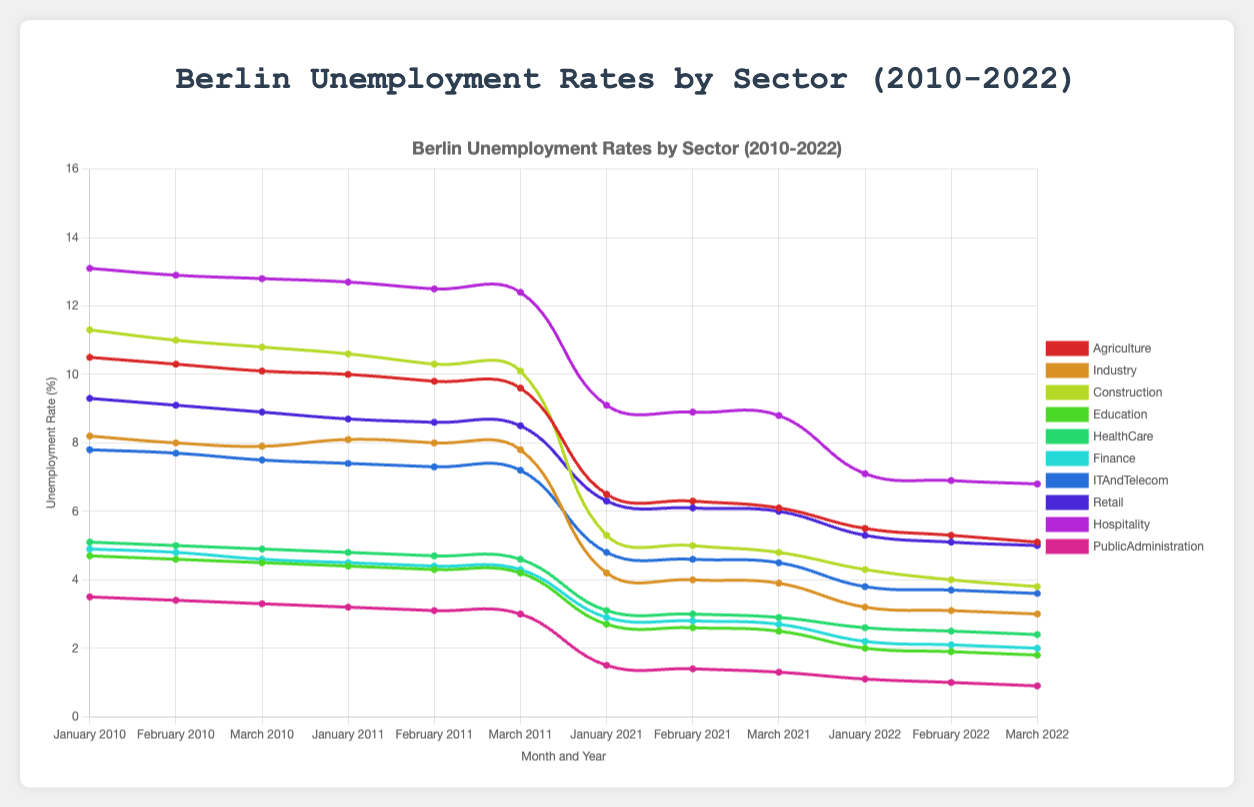What sector experienced the highest unemployment rate in January 2010? To identify the sector with the highest unemployment rate, look at the January 2010 data and compare all the sectors' unemployment rates. The highest value is 13.1 for the Hospitality sector.
Answer: Hospitality Which sector had the largest decrease in the unemployment rate from January 2011 to January 2022? To find the sector with the largest decrease, subtract the January 2022 unemployment rates from the January 2011 rates for each sector and identify the maximum difference. The most significant decrease is in the Hospitality sector, from 12.7 to 7.1, which is a drop of 5.6 percentage points.
Answer: Hospitality What is the average unemployment rate in the Finance sector across the years 2010 to 2022 for the month of January? To find the average, sum the unemployment rates for January from 2010 (4.9), 2011 (4.5), 2021 (2.9), and 2022 (2.2), then divide by the number of years. (4.9 + 4.5 + 2.9 + 2.2) / 4 = 3.625.
Answer: 3.625 Compare the unemployment rate in the Industry sector in March 2010 and March 2022. Which month had a lower rate? Compare the March 2010 and March 2022 rates for the Industry sector. March 2010 had a rate of 7.9% and March 2022 had 3.0%. Thus, March 2022 had a lower rate.
Answer: March 2022 Between January and March 2021, did the Retail sector experience an increase or decrease in the unemployment rate? By how much? Find the unemployment rates for January (6.3) and March (6.0) 2021 for the Retail sector. Subtract the March rate from January's (6.3 - 6.0), which shows a decrease of 0.3 percentage points.
Answer: Decrease, by 0.3 In which year and month did the Public Administration sector reach the lowest unemployment rate reported? Look through the years and months to find the lowest unemployment rate for Public Administration. The lowest rate is 0.9 in March 2022.
Answer: March 2022 How did the unemployment rate in the Education sector change from January 2010 to January 2021? Compare the unemployment rates for the Education sector in January 2010 (4.7) and January 2021 (2.7). The rate decreased by (4.7 - 2.7) 2.0 percentage points.
Answer: Decreased by 2.0 What is the sum of the unemployment rates for Agriculture and Construction sectors in February 2011? Add the unemployment rates for Agriculture (9.8) and Construction (10.3) in February 2011. 9.8 + 10.3 = 20.1.
Answer: 20.1 Which sector had the highest unemployment rate in March 2010, and did it remain the highest in March 2011? Identify the highest rate in March 2010 (12.8 in Hospitality) and compare with the highest in March 2011 (also Hospitality with 12.4). The highest remained in the Hospitality sector.
Answer: Hospitality, Yes Is there any sector that had an increasing unemployment trend from January to March 2022? Analyze the sectors from January to March 2022 whether the rates consistently increase. No sector shows a consistent increasing trend.
Answer: No 